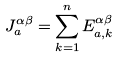<formula> <loc_0><loc_0><loc_500><loc_500>J _ { a } ^ { \alpha \beta } = \sum _ { k = 1 } ^ { n } E _ { a , k } ^ { \alpha \beta }</formula> 